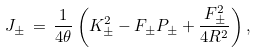Convert formula to latex. <formula><loc_0><loc_0><loc_500><loc_500>J _ { \pm } \, = \, \frac { 1 } { 4 \theta } \left ( K _ { \pm } ^ { 2 } - F _ { \pm } P _ { \pm } + \frac { F _ { \pm } ^ { 2 } } { 4 R ^ { 2 } } \right ) ,</formula> 